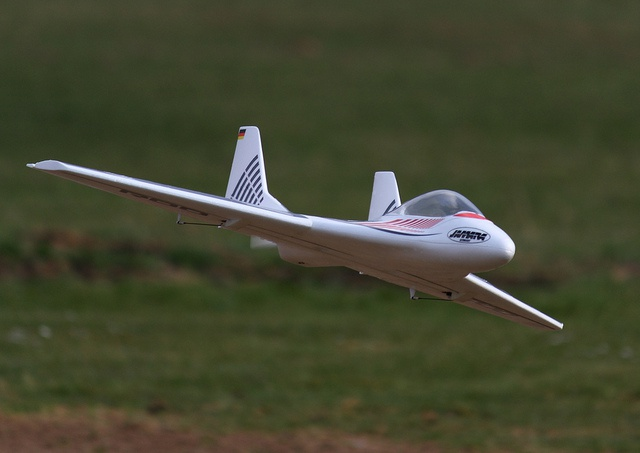Describe the objects in this image and their specific colors. I can see a airplane in darkgreen, black, darkgray, and gray tones in this image. 